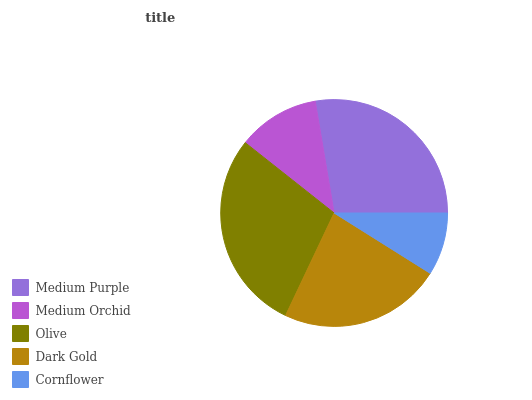Is Cornflower the minimum?
Answer yes or no. Yes. Is Olive the maximum?
Answer yes or no. Yes. Is Medium Orchid the minimum?
Answer yes or no. No. Is Medium Orchid the maximum?
Answer yes or no. No. Is Medium Purple greater than Medium Orchid?
Answer yes or no. Yes. Is Medium Orchid less than Medium Purple?
Answer yes or no. Yes. Is Medium Orchid greater than Medium Purple?
Answer yes or no. No. Is Medium Purple less than Medium Orchid?
Answer yes or no. No. Is Dark Gold the high median?
Answer yes or no. Yes. Is Dark Gold the low median?
Answer yes or no. Yes. Is Olive the high median?
Answer yes or no. No. Is Medium Orchid the low median?
Answer yes or no. No. 